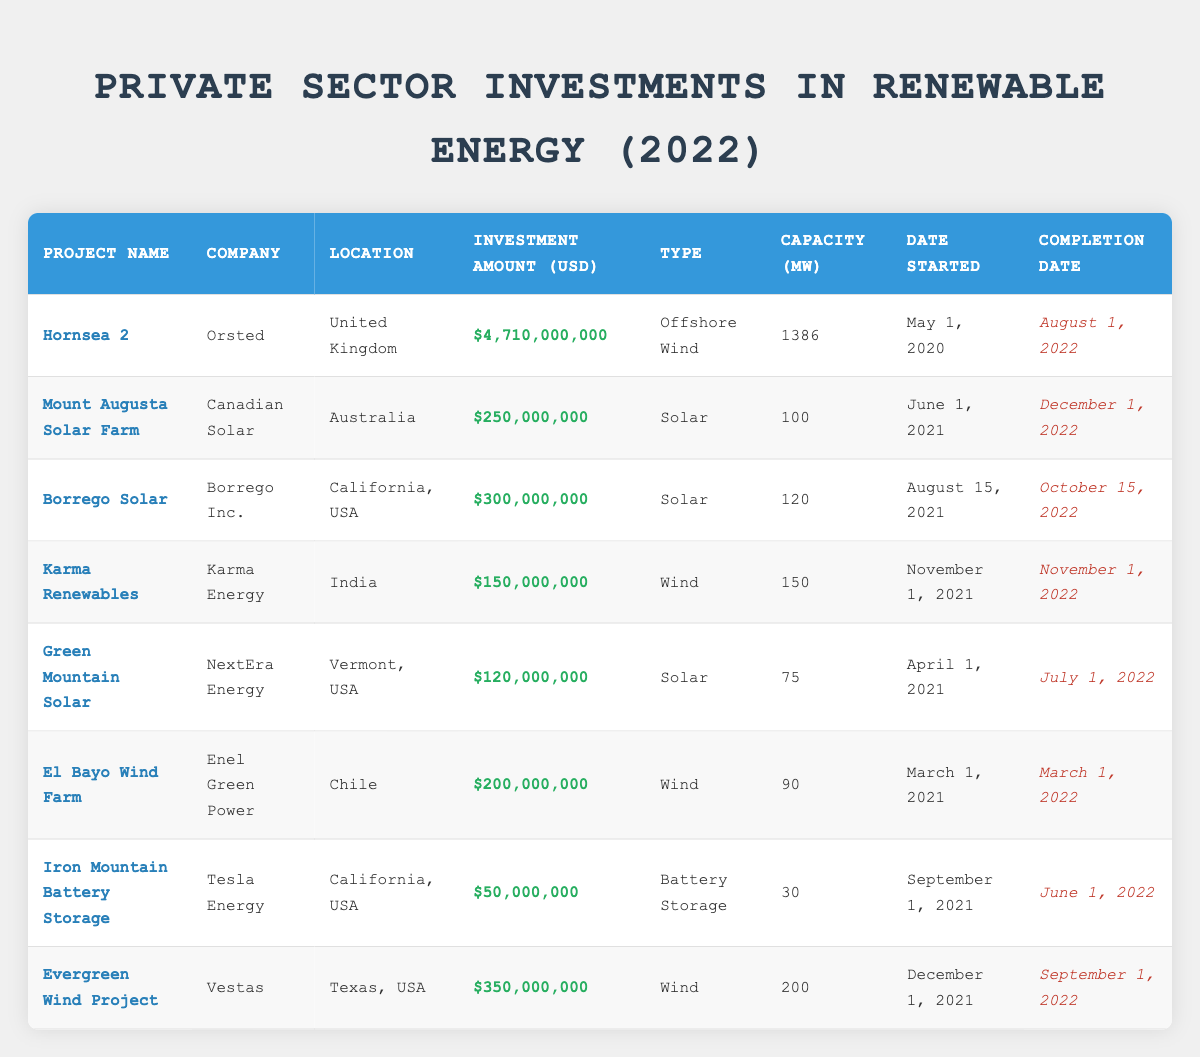What is the total investment amount in solar projects listed in the table? To find the total investment in solar projects, we need to retrieve the investment amounts for "Mount Augusta Solar Farm," "Borrego Solar," and "Green Mountain Solar." Adding these values gives: 250,000,000 + 300,000,000 + 120,000,000 = 670,000,000.
Answer: 670000000 Which company invested the most in renewable energy in 2022? By examining the investment amounts in the table, we find "Orsted" with an investment of 4,710,000,000 for the "Hornsea 2" project, which is the highest among all listed companies.
Answer: Orsted Is there a wind project with a capacity greater than 200 MW? Checking the capacity of all wind projects, we see "Hornsea 2" has a capacity of 1386 MW, "Evergreen Wind Project" has 200 MW, and "Karma Renewables" has 150 MW. There are no wind projects exceeding 200 MW, so the answer is false.
Answer: No What is the average investment amount for battery storage projects in this table? There is only one battery storage project listed, "Iron Mountain Battery Storage," with an investment amount of 50,000,000. Since there is only one data point, the average equals the investment amount itself: 50,000,000.
Answer: 50000000 Which project had the earliest completion date and what was it? Reviewing the completion dates, "El Bayo Wind Farm" completed on March 1, 2022, is the earliest date listed when comparing to others.
Answer: El Bayo Wind Farm, March 1, 2022 Can you name a solar project located in the USA? "Borrego Solar" is a solar project located in California, USA, as per the table's data, so the answer is affirmative.
Answer: Borrego Solar What is the total capacity of all wind projects mentioned in the table? The capacities of the wind projects in the table are: "Hornsea 2" (1386 MW), "Karma Renewables" (150 MW), and "Evergreen Wind Project" (200 MW). Total capacity calculation is: 1386 + 150 + 200 = 1736 MW.
Answer: 1736 Is Canadian Solar the company behind the "Hornsea 2" project? The "Hornsea 2" project is actually managed by "Orsted," not Canadian Solar, making this statement false.
Answer: No How many projects have an investment amount greater than 200 million USD? By checking the investment amounts, the projects over 200 million USD are "Hornsea 2" (4,710,000,000), "Borrego Solar" (300,000,000), "Evergreen Wind Project" (350,000,000), and "Karma Renewables" (150,000,000), totaling four projects with amounts exceeding 200 million USD.
Answer: 4 